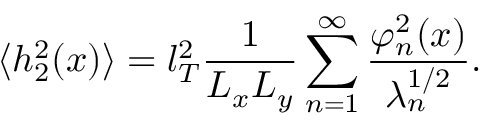<formula> <loc_0><loc_0><loc_500><loc_500>\langle h _ { 2 } ^ { 2 } ( x ) \rangle = l _ { T } ^ { 2 } \frac { 1 } { L _ { x } L _ { y } } \sum _ { n = 1 } ^ { \infty } \frac { \varphi _ { n } ^ { 2 } ( x ) } { \lambda _ { n } ^ { 1 / 2 } } .</formula> 